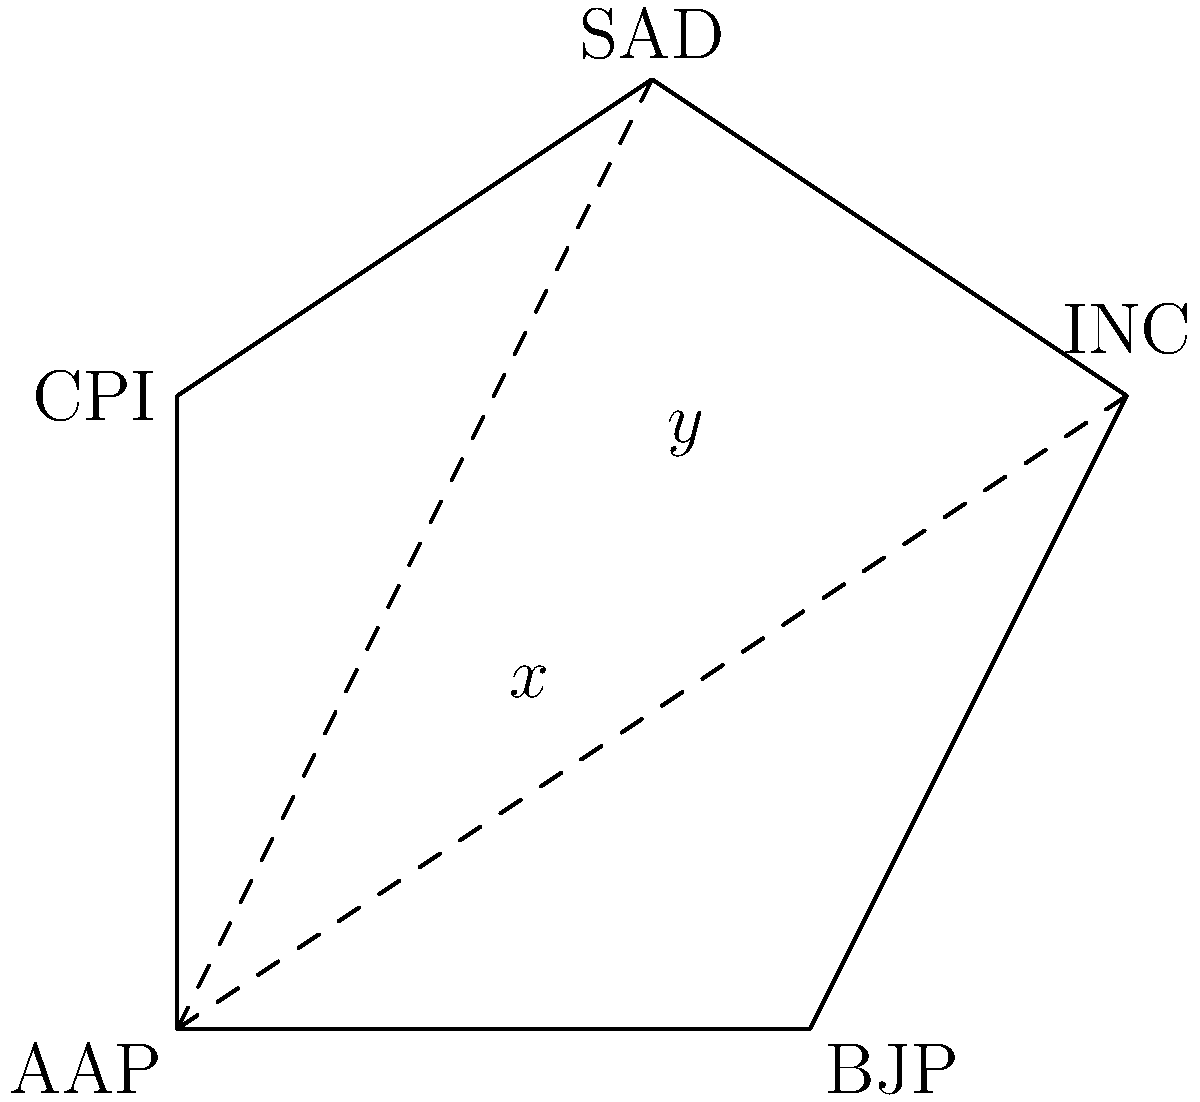In the pentagon representing the five main political parties in Punjab, two interior angles are marked as $x°$ and $y°$. If the sum of all interior angles in a pentagon is $540°$, what is the value of $x + y$? Let's approach this step-by-step:

1) First, recall that the sum of interior angles in a pentagon is always $540°$.

2) In the diagram, we see a pentagon divided into three triangles by two diagonals from one vertex.

3) We know that the sum of angles in a triangle is $180°$.

4) Therefore, the three triangles formed inside the pentagon have a total angle sum of $3 \times 180° = 540°$.

5) Two of these angles are marked as $x°$ and $y°$.

6) The remaining angles in these three triangles must sum to $540° - (x° + y°)$.

7) But we also know that these remaining angles, plus $x°$ and $y°$, must make up the full $540°$ of the pentagon.

8) This gives us the equation:
   $$(540° - (x° + y°)) + x° + y° = 540°$$

9) Simplifying:
   $$540° - x° - y° + x° + y° = 540°$$
   $$540° = 540°$$

10) This equation is always true, regardless of the values of $x$ and $y$.

Therefore, we cannot determine the exact value of $x + y$ with the given information. The sum could be any value between $0°$ and $540°$, as long as both $x$ and $y$ are positive and their sum is less than or equal to $540°$.
Answer: Cannot be determined 